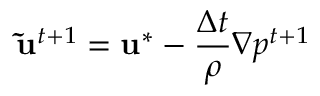Convert formula to latex. <formula><loc_0><loc_0><loc_500><loc_500>\widetilde { u } ^ { t + 1 } = u ^ { * } - \frac { \Delta t } { \rho } \nabla { p } ^ { t + 1 }</formula> 